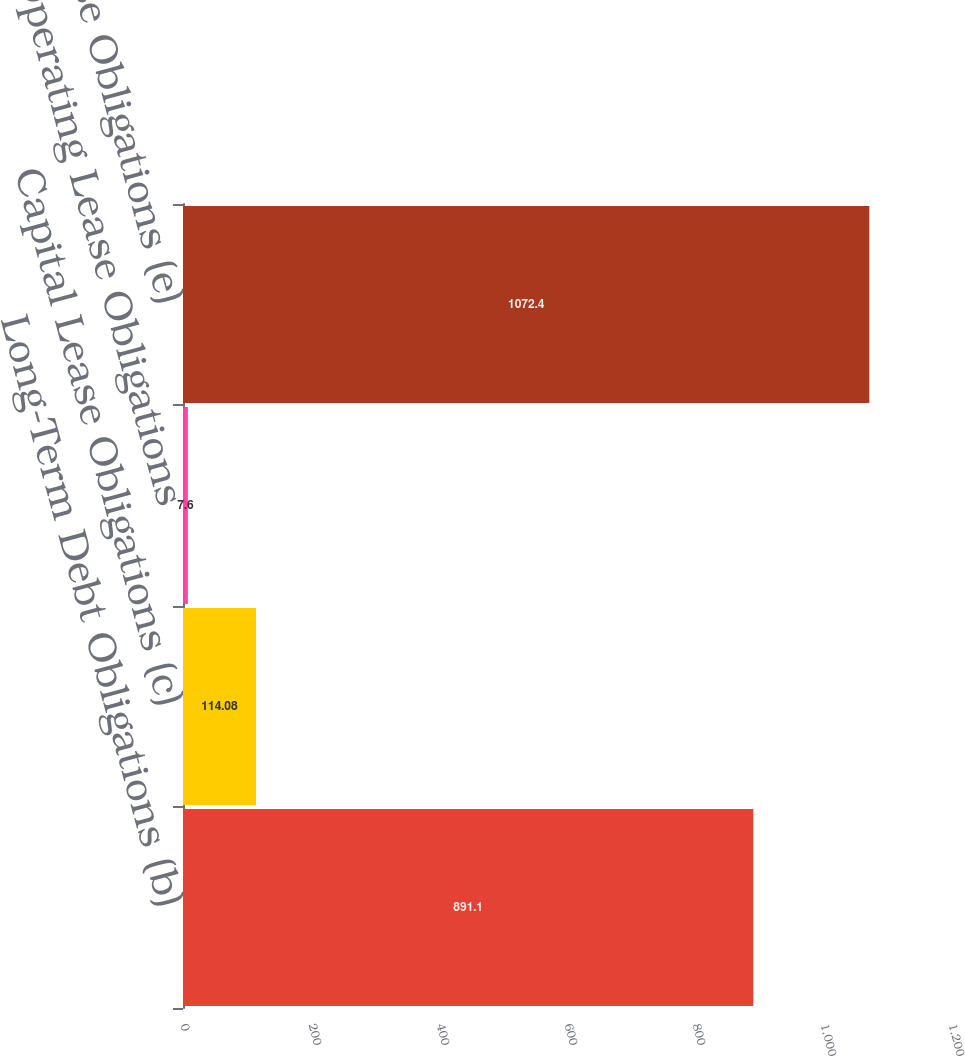<chart> <loc_0><loc_0><loc_500><loc_500><bar_chart><fcel>Long-Term Debt Obligations (b)<fcel>Capital Lease Obligations (c)<fcel>Operating Lease Obligations<fcel>Purchase Obligations (e)<nl><fcel>891.1<fcel>114.08<fcel>7.6<fcel>1072.4<nl></chart> 